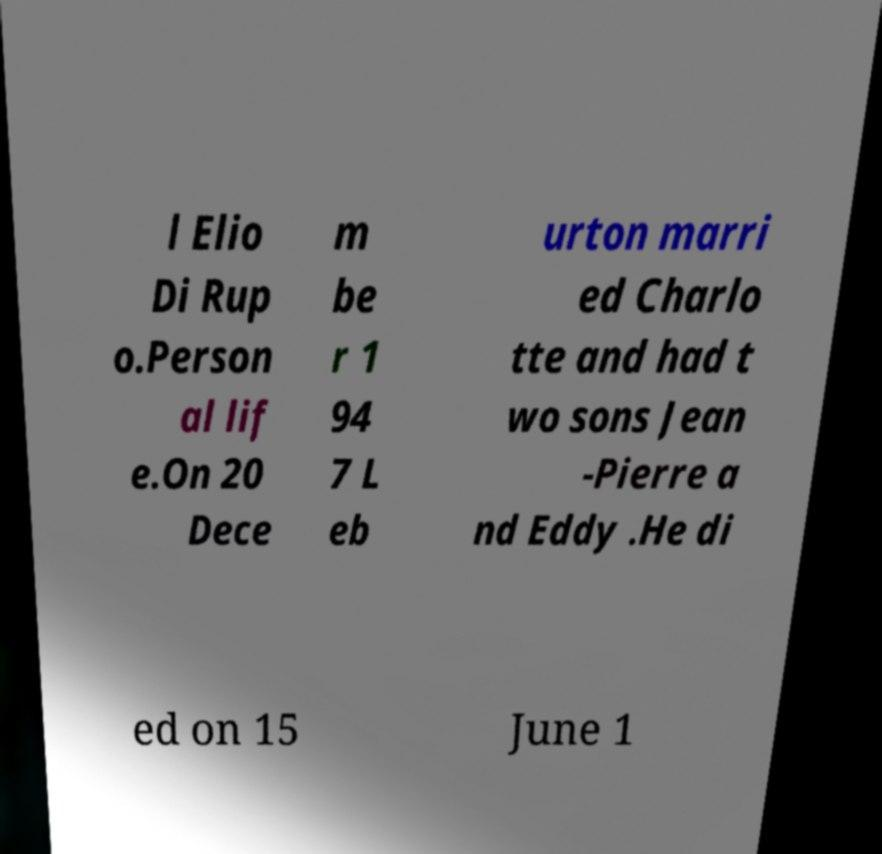What messages or text are displayed in this image? I need them in a readable, typed format. l Elio Di Rup o.Person al lif e.On 20 Dece m be r 1 94 7 L eb urton marri ed Charlo tte and had t wo sons Jean -Pierre a nd Eddy .He di ed on 15 June 1 